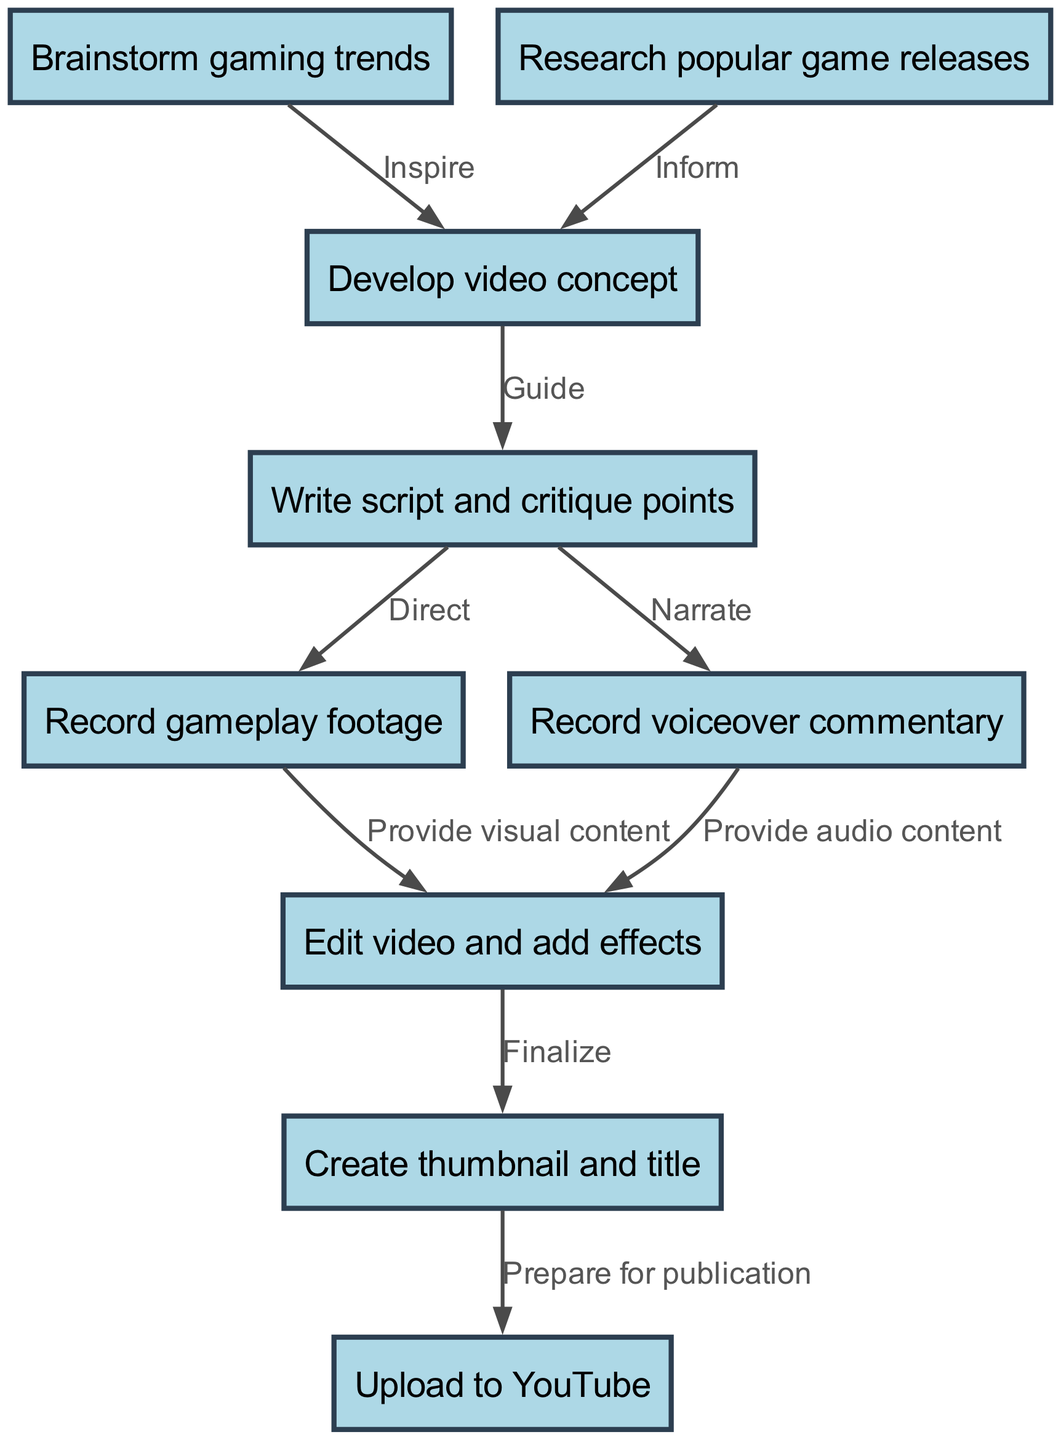What is the first step in the content creation pipeline? The first node is "Brainstorm gaming trends," which is where the process begins.
Answer: Brainstorm gaming trends How many nodes are there in the diagram? The diagram contains nine nodes that represent different steps in the content creation pipeline.
Answer: Nine What does the "Research popular game releases" step inform? This step informs the "Develop video concept" node, establishing a connection that guides concept development based on current trends.
Answer: Develop video concept Which two steps provide content for the "Edit video and add effects" node? The "Record gameplay footage" and "Record voiceover commentary" steps both provide visual and audio content, respectively, necessary for the editing process.
Answer: Record gameplay footage, Record voiceover commentary What is the relationship between "Create thumbnail and title" and "Upload to YouTube"? The "Create thumbnail and title" step prepares the finalized content for publication, leading directly to the "Upload to YouTube" step.
Answer: Prepare for publication What guides the transition from "Develop video concept" to "Write script and critique points"? The "Develop video concept" node guides the transition to the "Write script and critique points," as both processes are closely linked in content development.
Answer: Guide Which step follows "Edit video and add effects"? The step that follows "Edit video and add effects" is "Create thumbnail and title." This indicates that thumbnail creation occurs after video editing.
Answer: Create thumbnail and title What does the "Write script and critique points" step direct? This step directs both the "Record gameplay footage" and "Record voiceover commentary" steps, as it outlines what content needs to be captured and narrated.
Answer: Record gameplay footage, Record voiceover commentary What is the final step in the pipeline? The final node in the content creation pipeline is "Upload to YouTube," representing the completion of the process.
Answer: Upload to YouTube 